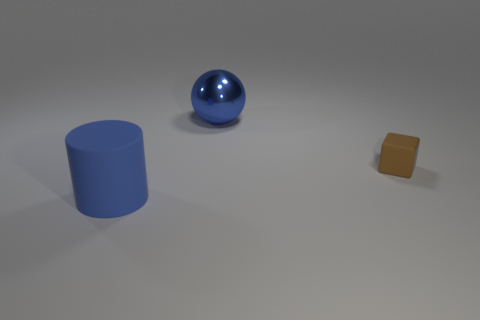Is there anything else that is the same size as the cube?
Your answer should be very brief. No. Do the large blue cylinder and the blue sphere have the same material?
Ensure brevity in your answer.  No. There is a matte object in front of the tiny matte object; how many large metallic objects are behind it?
Your response must be concise. 1. How many blue objects are cylinders or blocks?
Keep it short and to the point. 1. What shape is the blue object that is in front of the big thing behind the matte object that is left of the small brown object?
Ensure brevity in your answer.  Cylinder. What is the color of the rubber object that is the same size as the sphere?
Your response must be concise. Blue. How many big blue matte objects are the same shape as the tiny brown rubber object?
Provide a short and direct response. 0. Does the blue shiny sphere have the same size as the blue thing that is in front of the tiny brown rubber object?
Your answer should be very brief. Yes. The rubber object to the right of the large blue thing behind the tiny brown block is what shape?
Offer a very short reply. Cube. Is the number of large balls that are in front of the rubber cube less than the number of small metallic spheres?
Give a very brief answer. No. 